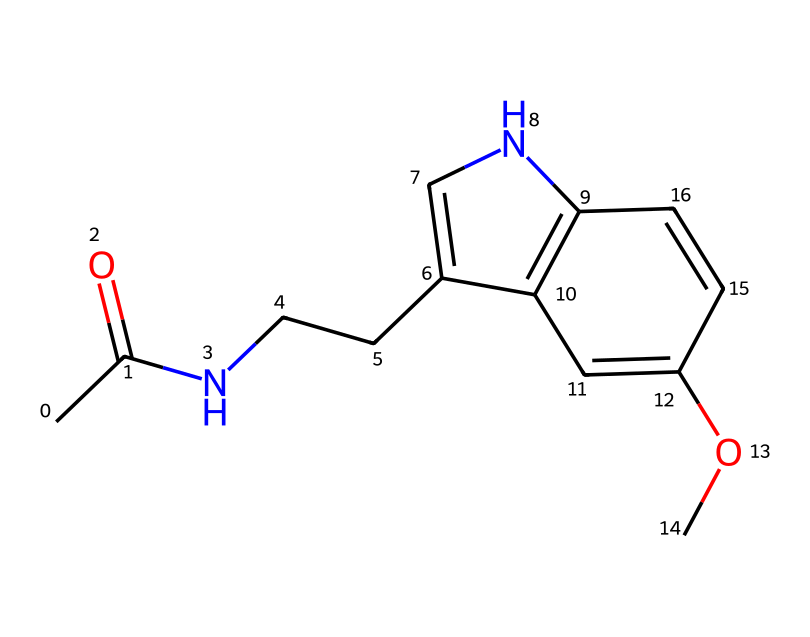What is the molecular formula of this chemical? To find the molecular formula, count the number of each type of atom in the structure represented by the SMILES. The SMILES indicates carbon (C), hydrogen (H), nitrogen (N), and oxygen (O) atoms. Counting gives us C13, H16, N2, O1.
Answer: C13H16N2O How many rings are present in this structure? Analyze the SMILES representation for any ring structures. The presence of a number indicates the start and end of a ring. The chemical has two numbered components indicating two ring structures.
Answer: 2 What type of functional group is present in this compound? Examine the structure for functional groups. Look for recognizable patterns; this compound has an amide (due to the "N" connected to a carbonyl) and an ether group (the "OC").
Answer: amide and ether What is the primary role of melatonin in the human body? Consider the known biological functions of melatonin. It is primarily known for regulating sleep-wake cycles and can help with jet lag.
Answer: sleep regulation Which element is indicated by the presence of "N" in the structure? Identify the symbol "N" in the SMILES representation, which corresponds to nitrogen. It indicates the presence of nitrogen atoms in the structure.
Answer: nitrogen How does the presence of oxygen influence the properties of this compound? Evaluate the role of oxygen. The oxygen in the amide and ether groups contributes to polar characteristics, which can enhance solubility in water and reactivity.
Answer: increases polarity and solubility What is the common name for this molecule? This compound is widely known and can be easily recognized from its chemical structure. Melatonin is the common name for this molecule.
Answer: melatonin 